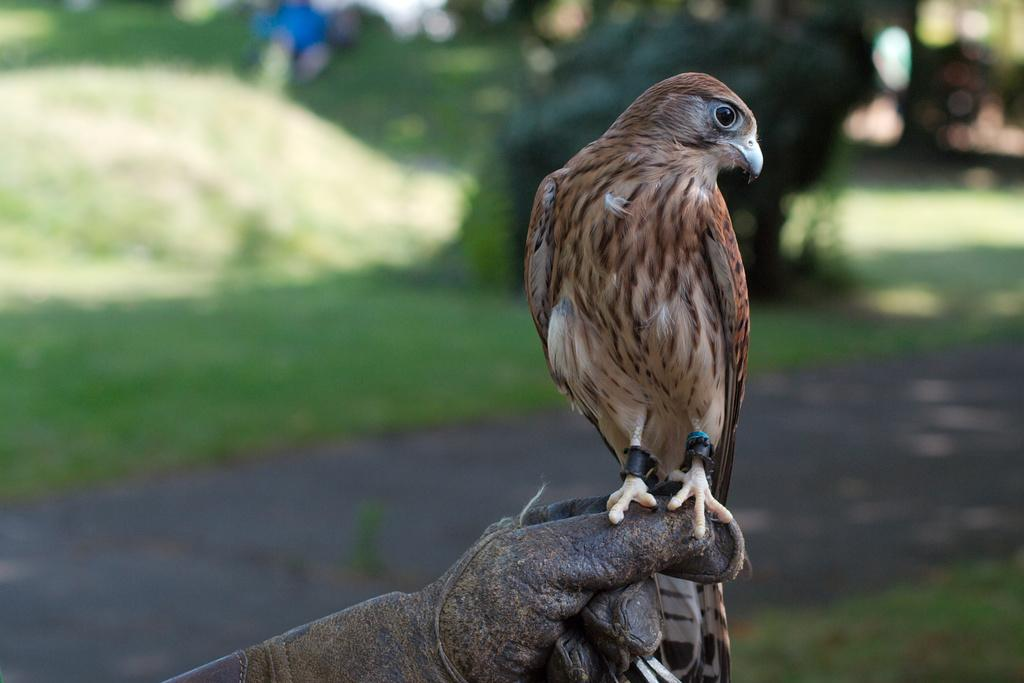What type of animal can be seen in the image? There is a bird in the image. Where is the bird located in the image? The bird is on an object. What can be seen in the background of the image? There is a road, grass, and trees visible in the background of the image. What type of juice is the bird drinking in the image? There is no juice present in the image; it features a bird on an object with a background of a road, grass, and trees. 